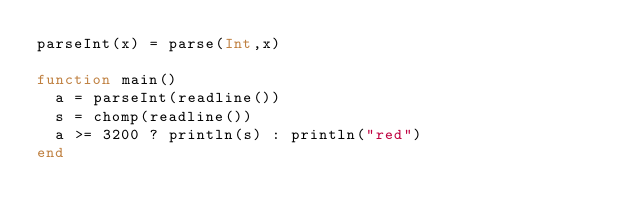Convert code to text. <code><loc_0><loc_0><loc_500><loc_500><_Julia_>parseInt(x) = parse(Int,x)

function main()
  a = parseInt(readline())
  s = chomp(readline())
  a >= 3200 ? println(s) : println("red")
end</code> 